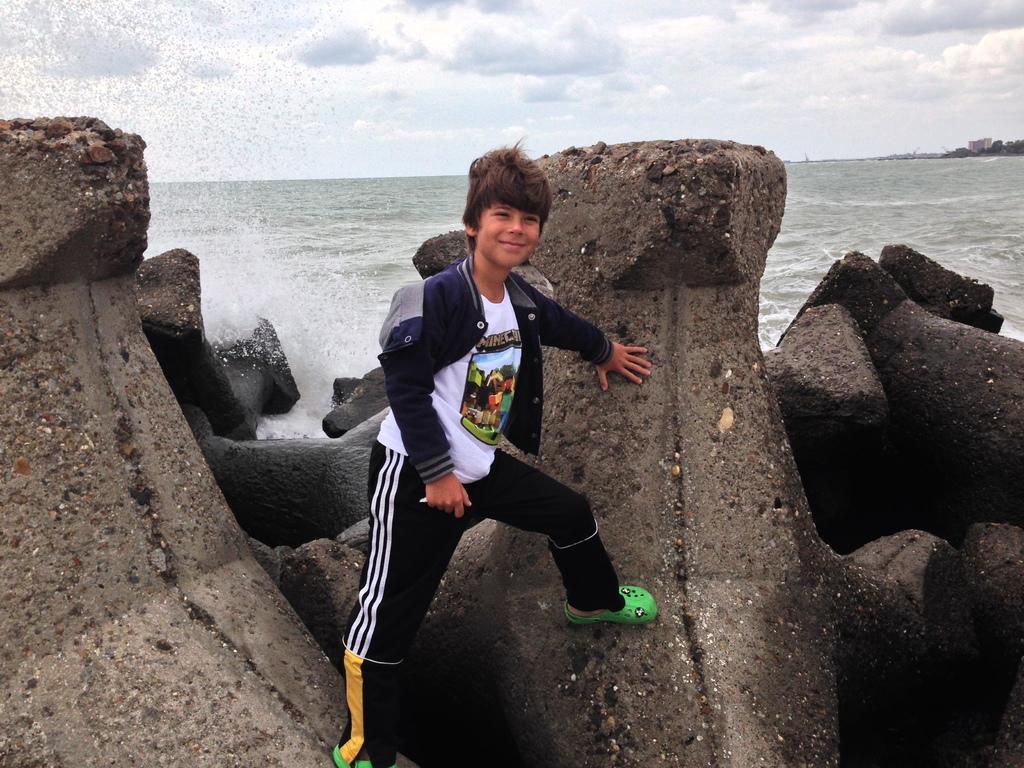Please provide a concise description of this image. In this image, I can see a boy standing and smiling. These are the rocks. I think this is the sea. On the right side of the image, I can see a building and the trees. These are the clouds in the sky. 